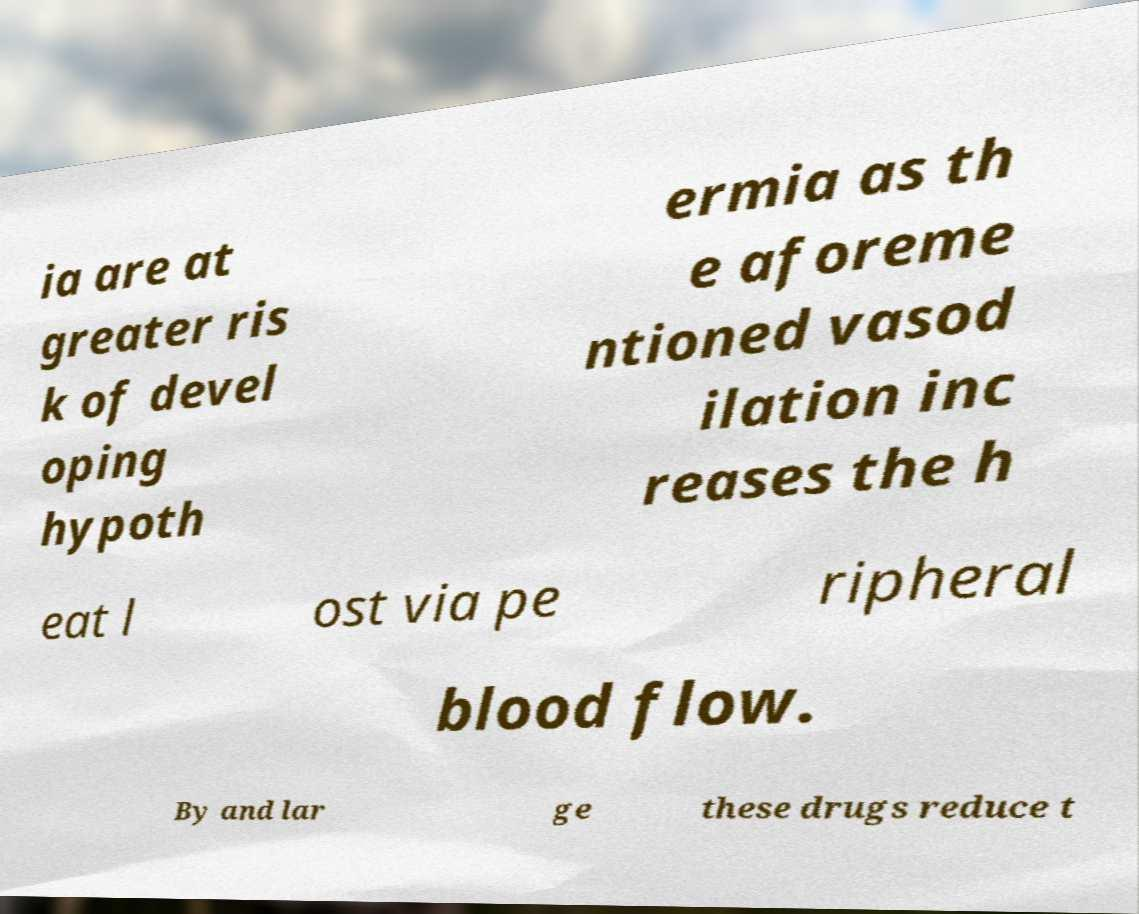For documentation purposes, I need the text within this image transcribed. Could you provide that? ia are at greater ris k of devel oping hypoth ermia as th e aforeme ntioned vasod ilation inc reases the h eat l ost via pe ripheral blood flow. By and lar ge these drugs reduce t 